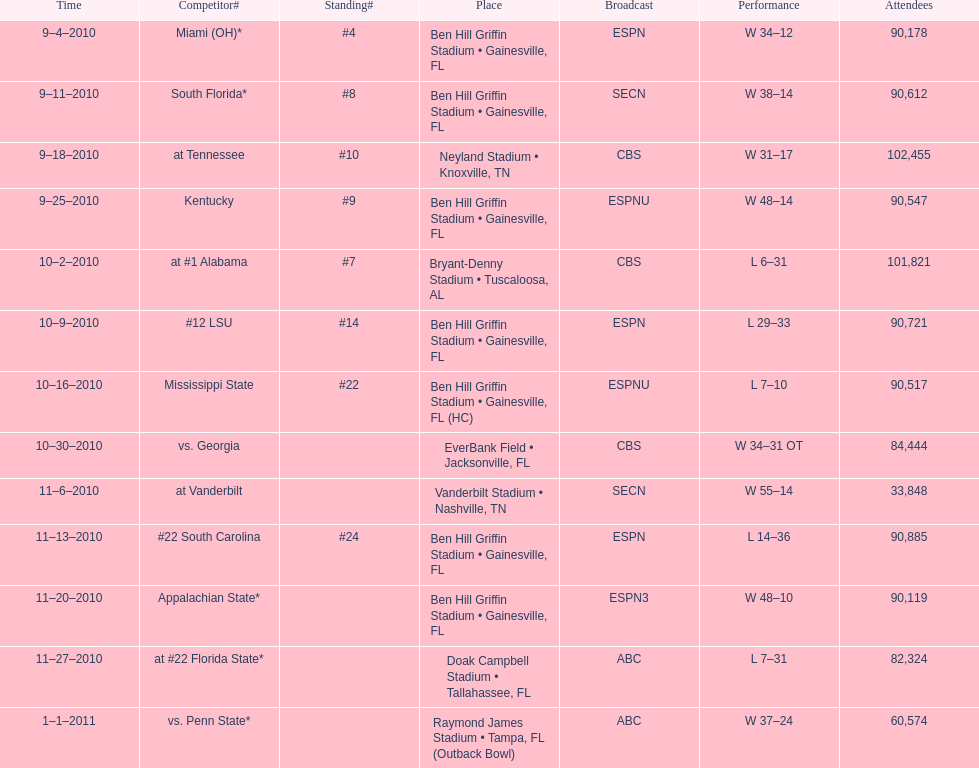How many games did the university of florida win by at least 10 points? 7. 